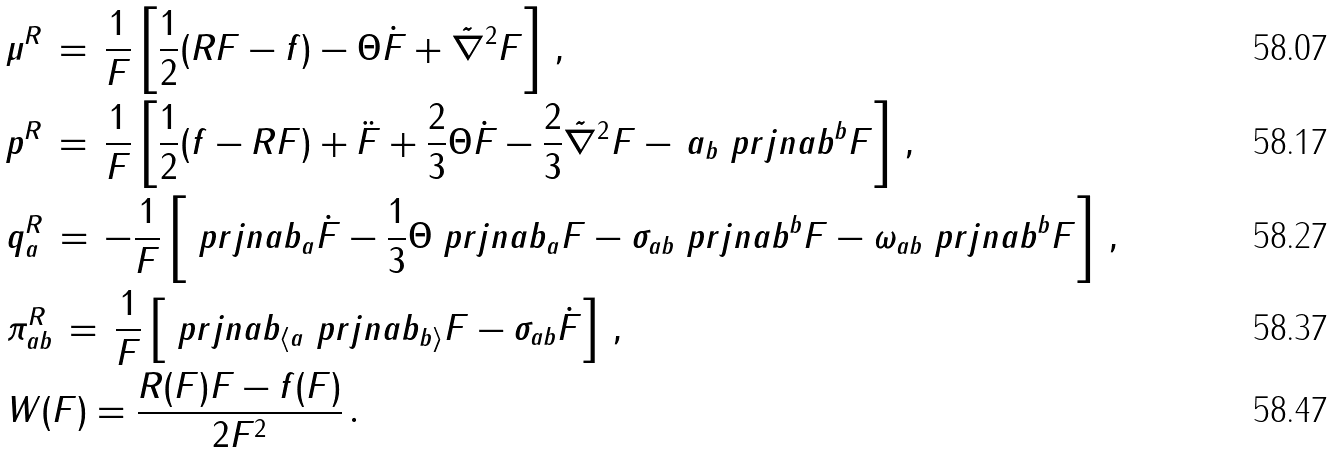<formula> <loc_0><loc_0><loc_500><loc_500>& \mu ^ { R } \, = \, \frac { 1 } { F } \left [ \frac { 1 } { 2 } ( R F - f ) - \Theta \dot { F } + \tilde { \nabla } ^ { 2 } { F } \right ] \, , \\ & p ^ { R } \, = \, \frac { 1 } { F } \left [ \frac { 1 } { 2 } ( f - R F ) + \ddot { F } + \frac { 2 } { 3 } \Theta \dot { F } - \frac { 2 } { 3 } \tilde { \nabla } ^ { 2 } { F } - \, a _ { b } \ p r j n a b ^ { b } { F } \right ] \, , \\ & q ^ { R } _ { a } \, = \, - \frac { 1 } { F } \left [ \ p r j n a b _ { a } \dot { F } - \frac { 1 } { 3 } \Theta \ p r j n a b _ { a } F - \sigma _ { a b } \ p r j n a b ^ { b } F - \omega _ { a b } \ p r j n a b ^ { b } F \right ] \, , \\ & \pi ^ { R } _ { a b } \, = \, \frac { 1 } { F } \left [ \ p r j n a b _ { \langle a } \ p r j n a b _ { b \rangle } F - \sigma _ { a b } \dot { F } \right ] \, , \\ & W ( F ) = \frac { R ( F ) F - f ( F ) } { 2 F ^ { 2 } } \, .</formula> 